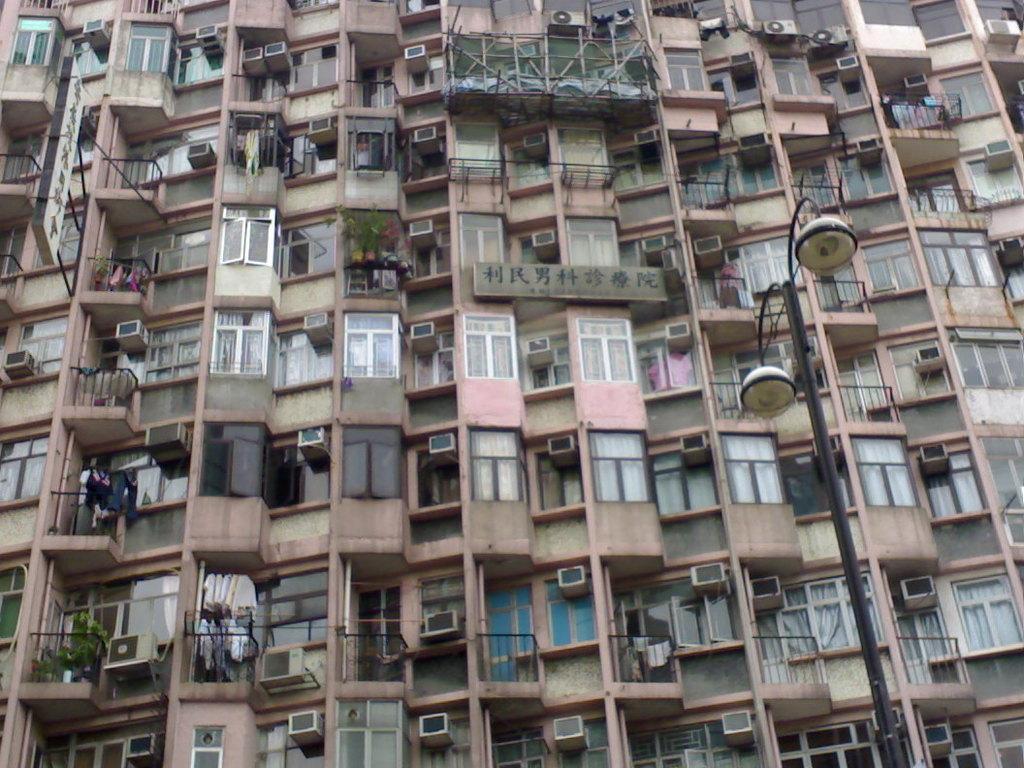Please provide a concise description of this image. In this picture we can see few buildings, lights, poles, hoardings, cloths, plants and air conditioners. 